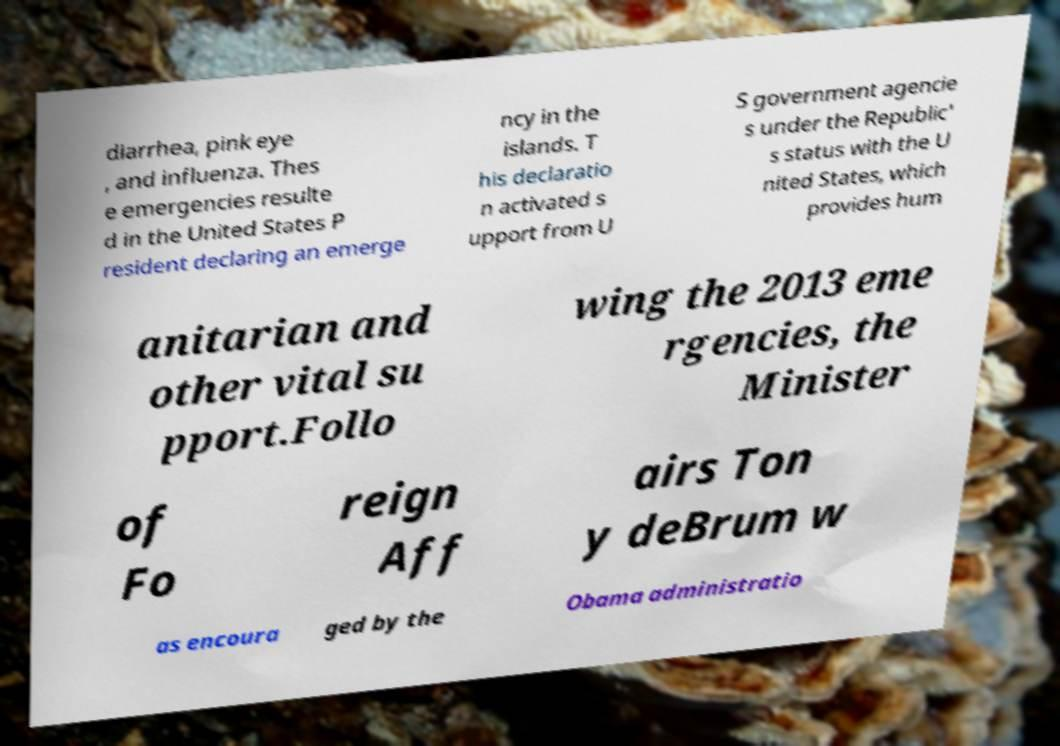What messages or text are displayed in this image? I need them in a readable, typed format. diarrhea, pink eye , and influenza. Thes e emergencies resulte d in the United States P resident declaring an emerge ncy in the islands. T his declaratio n activated s upport from U S government agencie s under the Republic' s status with the U nited States, which provides hum anitarian and other vital su pport.Follo wing the 2013 eme rgencies, the Minister of Fo reign Aff airs Ton y deBrum w as encoura ged by the Obama administratio 